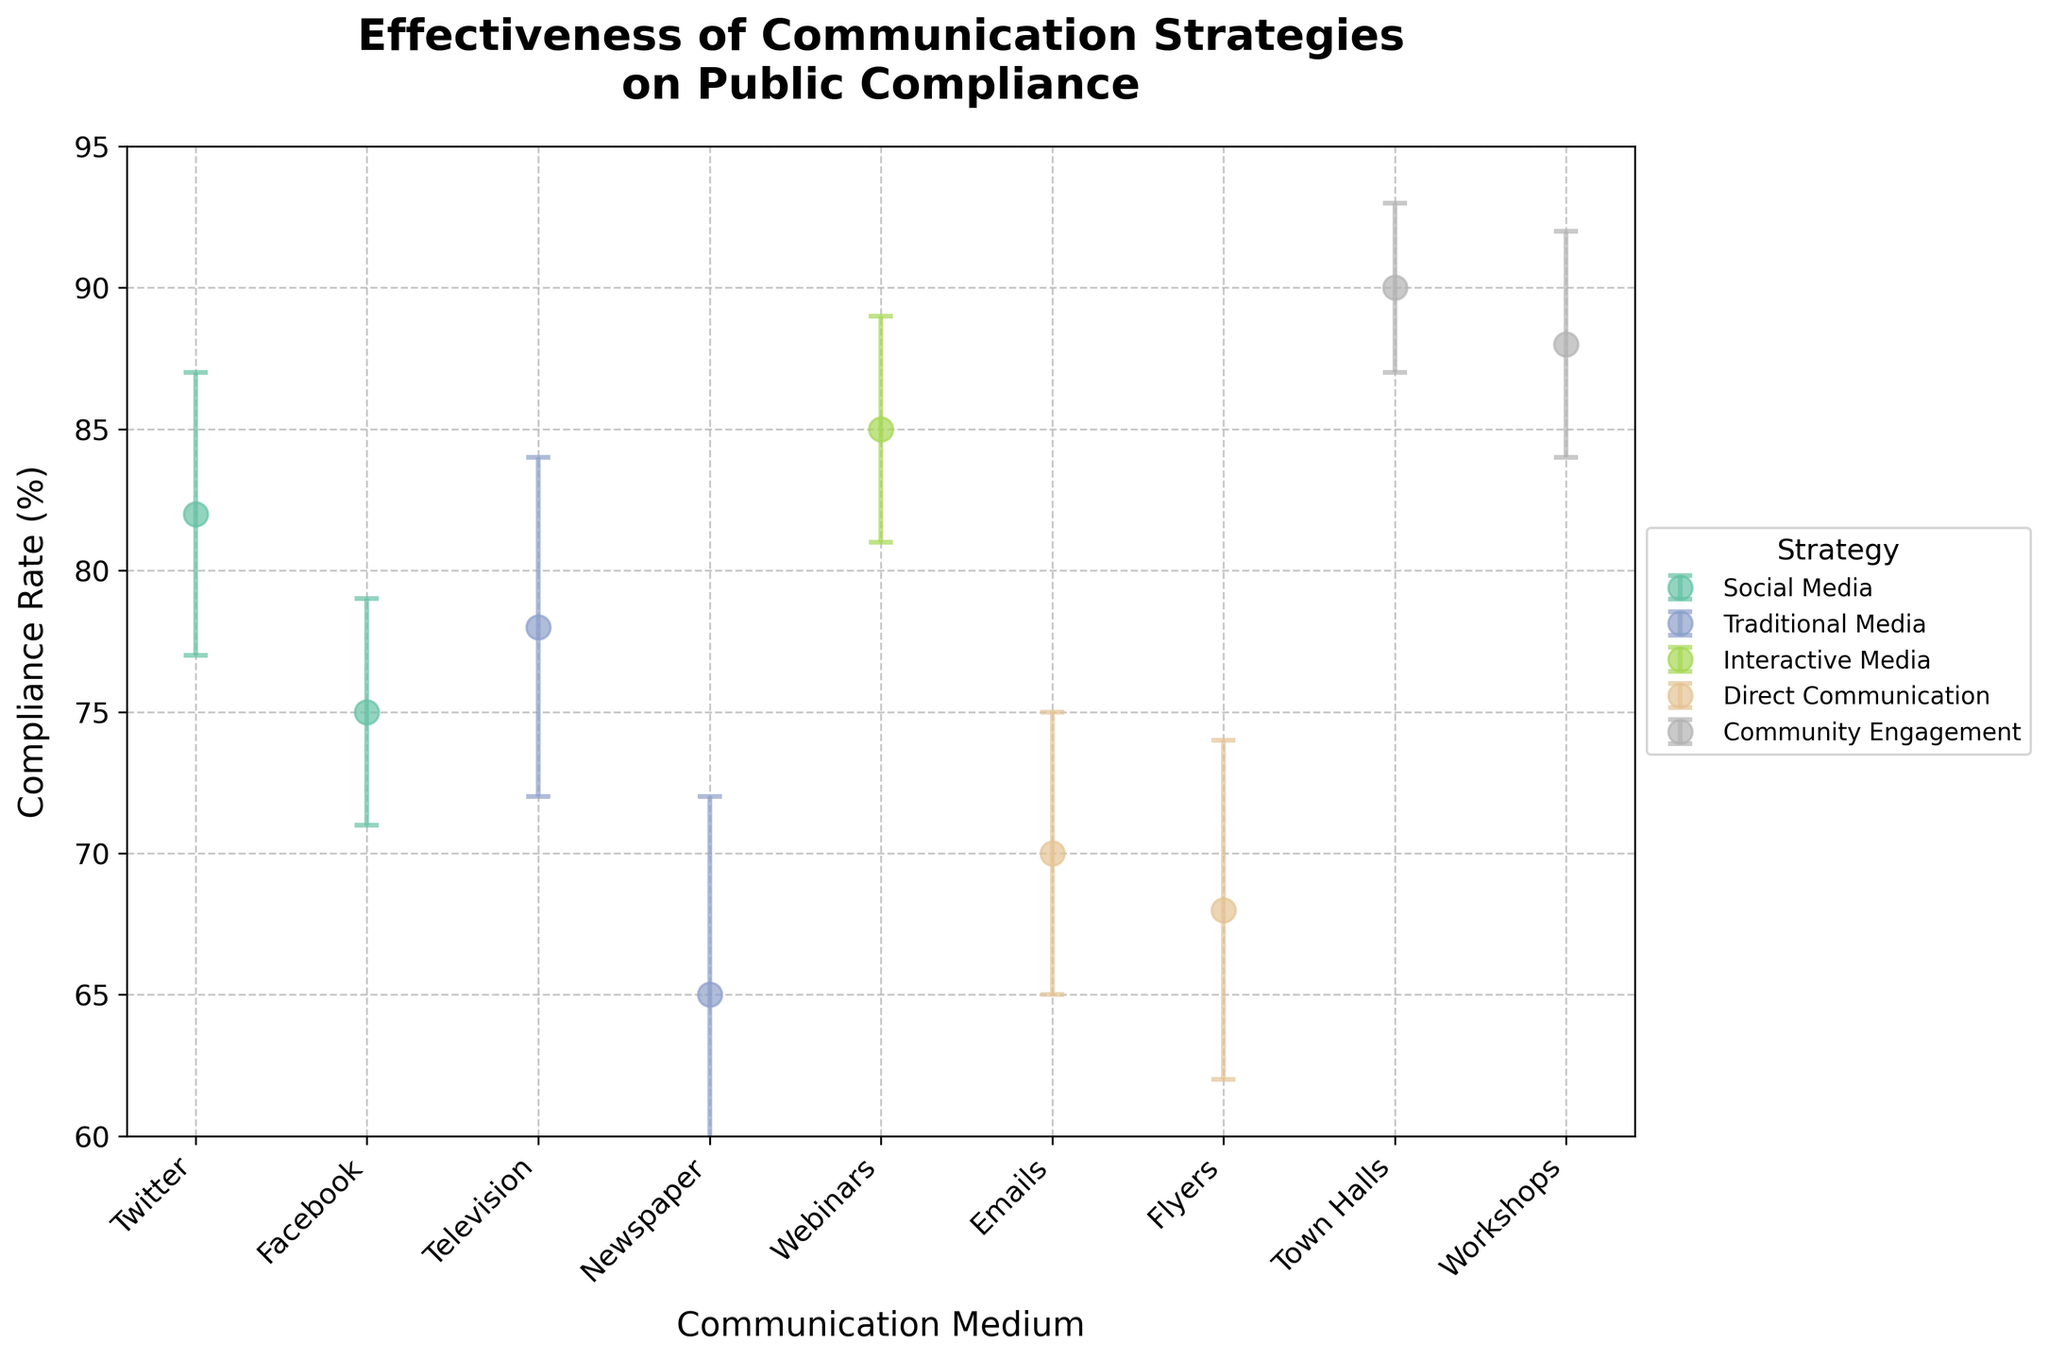What is the medium with the highest compliance rate? The medium with the highest compliance rate can be identified by looking at the point that is plotted highest on the y-axis. Town Halls have a compliance rate of 90%, which is the highest.
Answer: Town Halls How does the compliance rate of Facebook compare to Twitter? Facebook and Twitter are both part of the Social Media strategy. Refer to their respective points; Facebook has a compliance rate of 75%, while Twitter has a compliance rate of 82%. Thus, Twitter's compliance rate is higher than Facebook's.
Answer: Twitter's compliance rate is higher What is the average compliance rate for Community Engagement mediums? The Community Engagement strategy includes Town Halls and Workshops with compliance rates of 90% and 88%, respectively. To find the average: (90 + 88) / 2 = 89.
Answer: 89 Which strategy has the largest variability in compliance rate? Variability can be assessed by the length of the error bars. The Newspaper (part of the Traditional Media strategy) has the longest error bars of 7%. Therefore, Traditional Media has the largest variability.
Answer: Traditional Media How many different communication strategies are shown in the figure? The number of unique colors indicates the number of different strategies. From the legend, we can count the strategies: Social Media, Traditional Media, Interactive Media, Direct Communication, and Community Engagement.
Answer: 5 What is the compliance rate range for Direct Communication? Direct Communication includes Emails (70%) and Flyers (68%). The range is the difference between the highest rate and the lowest rate: 70% - 68% = 2%.
Answer: 2% Which communication medium has the lowest compliance rate? The lowest point on the y-axis represents the lowest compliance rate. Newspaper (part of Traditional Media) has the lowest compliance rate at 65%.
Answer: Newspaper What is the difference in compliance rates between the highest medium in Community Engagement and the lowest medium in Direct Communication? The highest medium in Community Engagement is Town Halls (90%), and the lowest medium in Direct Communication is Flyers (68%). The difference is: 90% - 68% = 22%.
Answer: 22% Are error bars for Interactive Media mediums smaller on average compared to those of Traditional Media? Interactive Media (Webinars) has an error bar of 4%. Traditional Media includes Television (6%) and Newspaper (7%). The average error for Traditional Media is (6 + 7) / 2 = 6.5%. Comparing, 4% is indeed smaller than 6.5%.
Answer: Yes What is the compliance rate for the Twitter medium, and what is its error margin? The compliance rate for Twitter is indicated as 82%, with an error margin of 5% shown by the length of the error bar.
Answer: 82% and 5% 